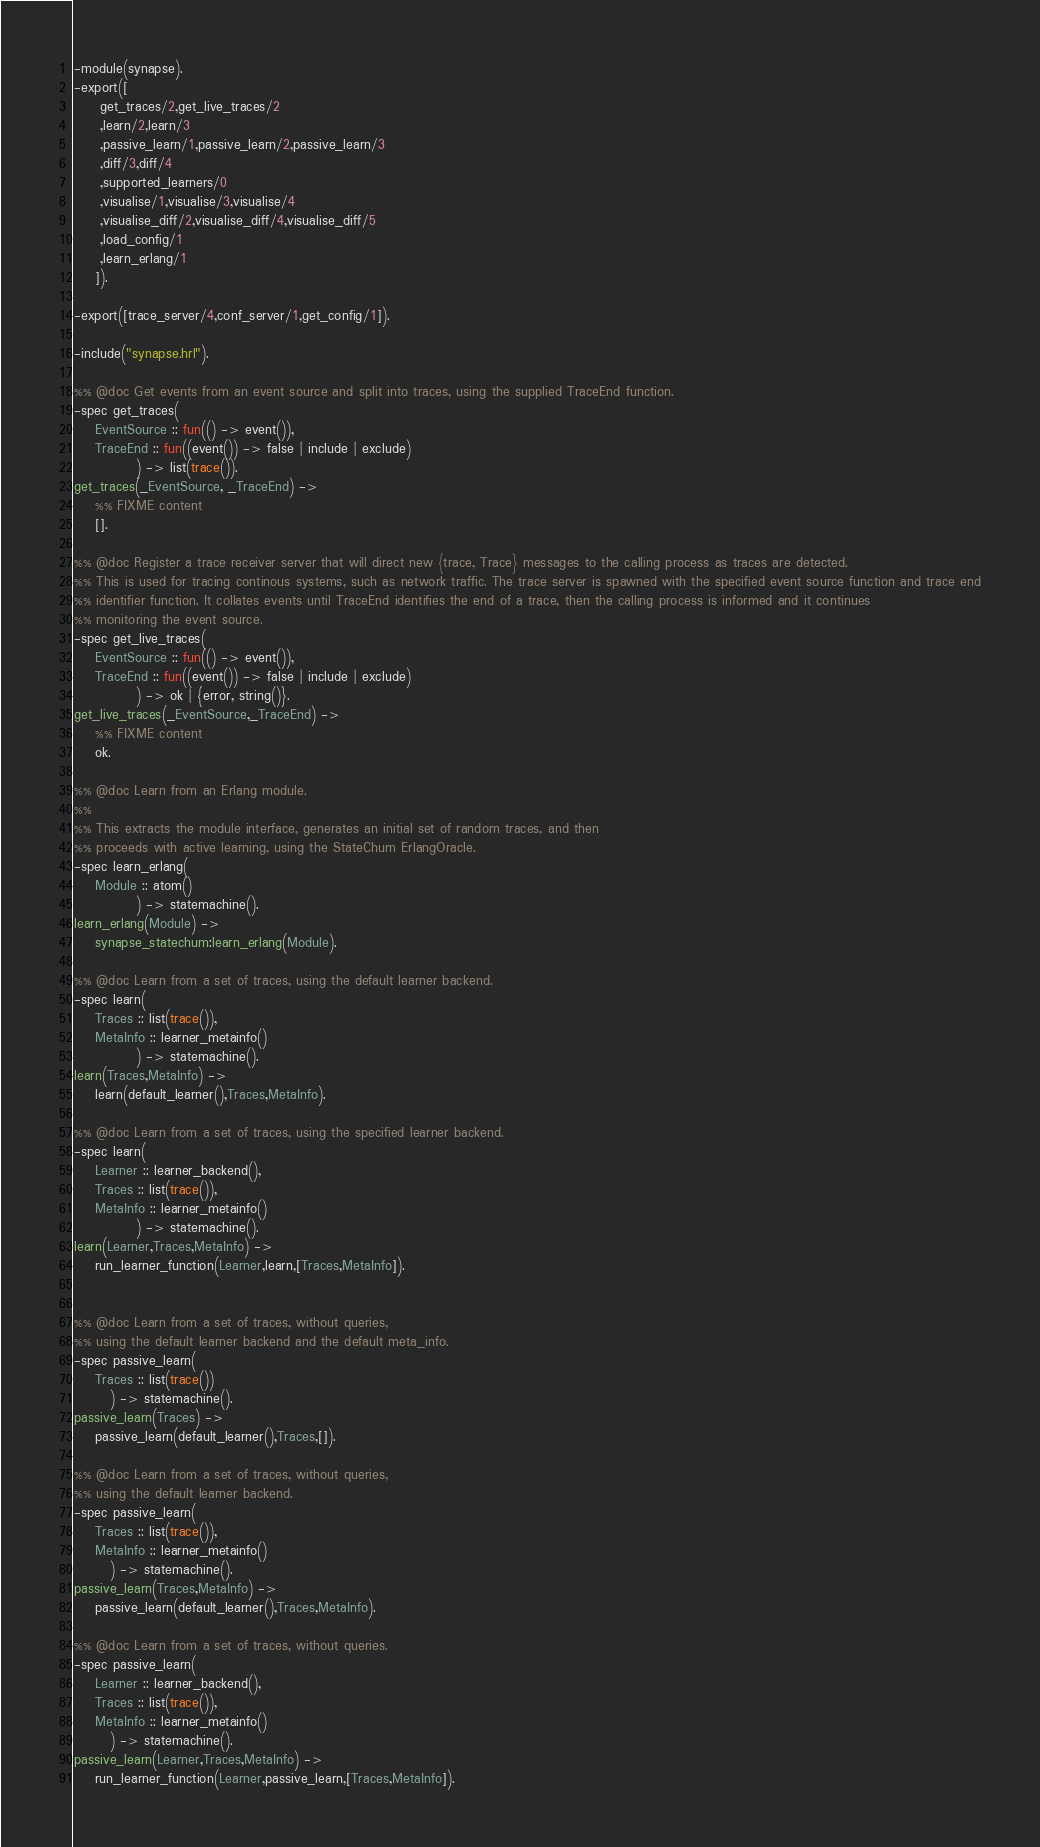Convert code to text. <code><loc_0><loc_0><loc_500><loc_500><_Erlang_>-module(synapse).
-export([
	 get_traces/2,get_live_traces/2
	 ,learn/2,learn/3
	 ,passive_learn/1,passive_learn/2,passive_learn/3
	 ,diff/3,diff/4
	 ,supported_learners/0
	 ,visualise/1,visualise/3,visualise/4
	 ,visualise_diff/2,visualise_diff/4,visualise_diff/5
	 ,load_config/1
	 ,learn_erlang/1
	]).

-export([trace_server/4,conf_server/1,get_config/1]).

-include("synapse.hrl").

%% @doc Get events from an event source and split into traces, using the supplied TraceEnd function.
-spec get_traces(
	EventSource :: fun(() -> event()), 
	TraceEnd :: fun((event()) -> false | include | exclude)
		    ) -> list(trace()).
get_traces(_EventSource, _TraceEnd) ->
    %% FIXME content
    [].

%% @doc Register a trace receiver server that will direct new {trace, Trace} messages to the calling process as traces are detected.
%% This is used for tracing continous systems, such as network traffic. The trace server is spawned with the specified event source function and trace end
%% identifier function. It collates events until TraceEnd identifies the end of a trace, then the calling process is informed and it continues
%% monitoring the event source.
-spec get_live_traces(
	EventSource :: fun(() -> event()), 
	TraceEnd :: fun((event()) -> false | include | exclude)
		    ) -> ok | {error, string()}.
get_live_traces(_EventSource,_TraceEnd) ->
    %% FIXME content
    ok.

%% @doc Learn from an Erlang module.
%%
%% This extracts the module interface, generates an initial set of random traces, and then
%% proceeds with active learning, using the StateChum ErlangOracle.
-spec learn_erlang(
	Module :: atom()
		    ) -> statemachine().
learn_erlang(Module) ->
    synapse_statechum:learn_erlang(Module).

%% @doc Learn from a set of traces, using the default learner backend.
-spec learn(
	Traces :: list(trace()),
	MetaInfo :: learner_metainfo()
		    ) -> statemachine().
learn(Traces,MetaInfo) ->
    learn(default_learner(),Traces,MetaInfo).

%% @doc Learn from a set of traces, using the specified learner backend.
-spec learn(
	Learner :: learner_backend(),
	Traces :: list(trace()),
	MetaInfo :: learner_metainfo()
		    ) -> statemachine().
learn(Learner,Traces,MetaInfo) ->
    run_learner_function(Learner,learn,[Traces,MetaInfo]).


%% @doc Learn from a set of traces, without queries, 
%% using the default learner backend and the default meta_info.
-spec passive_learn(
	Traces :: list(trace())
       ) -> statemachine().
passive_learn(Traces) ->
    passive_learn(default_learner(),Traces,[]).

%% @doc Learn from a set of traces, without queries, 
%% using the default learner backend.
-spec passive_learn(
	Traces :: list(trace()),
	MetaInfo :: learner_metainfo()
       ) -> statemachine().
passive_learn(Traces,MetaInfo) ->
    passive_learn(default_learner(),Traces,MetaInfo).

%% @doc Learn from a set of traces, without queries.
-spec passive_learn(
	Learner :: learner_backend(),
	Traces :: list(trace()),
	MetaInfo :: learner_metainfo()
       ) -> statemachine().
passive_learn(Learner,Traces,MetaInfo) ->
    run_learner_function(Learner,passive_learn,[Traces,MetaInfo]).
</code> 